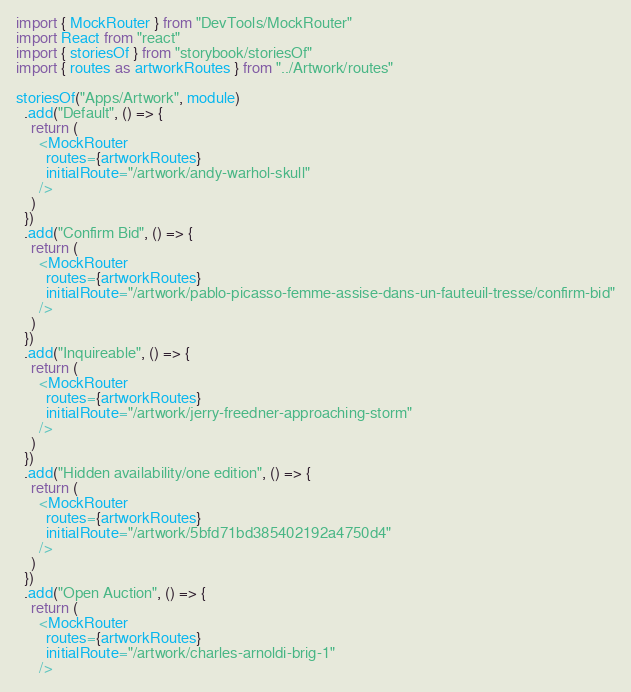<code> <loc_0><loc_0><loc_500><loc_500><_TypeScript_>import { MockRouter } from "DevTools/MockRouter"
import React from "react"
import { storiesOf } from "storybook/storiesOf"
import { routes as artworkRoutes } from "../Artwork/routes"

storiesOf("Apps/Artwork", module)
  .add("Default", () => {
    return (
      <MockRouter
        routes={artworkRoutes}
        initialRoute="/artwork/andy-warhol-skull"
      />
    )
  })
  .add("Confirm Bid", () => {
    return (
      <MockRouter
        routes={artworkRoutes}
        initialRoute="/artwork/pablo-picasso-femme-assise-dans-un-fauteuil-tresse/confirm-bid"
      />
    )
  })
  .add("Inquireable", () => {
    return (
      <MockRouter
        routes={artworkRoutes}
        initialRoute="/artwork/jerry-freedner-approaching-storm"
      />
    )
  })
  .add("Hidden availability/one edition", () => {
    return (
      <MockRouter
        routes={artworkRoutes}
        initialRoute="/artwork/5bfd71bd385402192a4750d4"
      />
    )
  })
  .add("Open Auction", () => {
    return (
      <MockRouter
        routes={artworkRoutes}
        initialRoute="/artwork/charles-arnoldi-brig-1"
      /></code> 